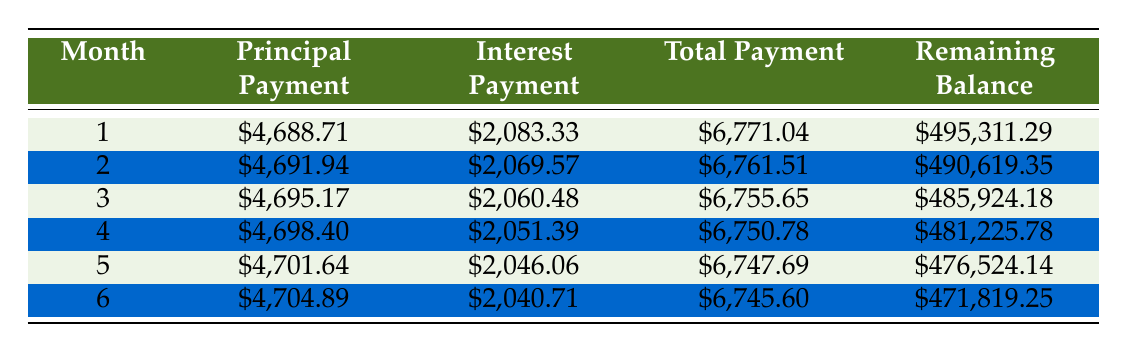What is the principal payment in the first month? The table shows the principal payment for month 1 as $4,688.71. Thus, the answer can be directly retrieved from the first row under the Principal Payment column.
Answer: 4,688.71 What is the total payment for month 3? The table indicates that the total payment for month 3 is $6,755.65. This value can be found in the row corresponding to month 3 in the Total Payment column.
Answer: 6,755.65 Is the interest payment for month 2 greater than that for month 1? The interest payment for month 2 is $2,069.57 and for month 1, it is $2,083.33. Since $2,069.57 is less than $2,083.33, the answer is no.
Answer: No What is the total of the principal payments for the first six months? To find the total of the principal payments, add the amounts from the principal payment column for the first six months: $4,688.71 + $4,691.94 + $4,695.17 + $4,698.40 + $4,701.64 + $4,704.89 = $28,480.75. This gives the total amount of principal paid over these six months.
Answer: 28,480.75 What month has the highest interest payment? Reviewing the interest payments for each month, the highest payment occurs in month 1 at $2,083.33. This can be concluded by comparing the interest payment values across all rows.
Answer: Month 1 What is the remaining balance after the 6th month? The remaining balance after the 6th month can be found in the table in the row corresponding to month 6. It shows $471,819.25, which is the remaining loan amount after six payments.
Answer: 471,819.25 If you sum up the total payments for the first three months, what is the total? To find the total payments for the first three months, sum the total payments for each month: $6,771.04 (month 1) + $6,761.51 (month 2) + $6,755.65 (month 3) = $20,288.20. Thus, this provides the total outflow associated with these payments.
Answer: 20,288.20 Is the expected monthly revenue greater than the total payments in the first month? The expected monthly revenue is $6,000, and the total payment for month 1 is $6,771.04. Since $6,000 is less than $6,771.04, the answer is no.
Answer: No How much has been paid off in principal after the first three months? To determine how much has been paid off in principal after three months, add the principal payments for month 1, month 2, and month 3: $4,688.71 + $4,691.94 + $4,695.17 = $14,075.82. This gives us the total amount of the loan that has been repaid due to principal payments over these months.
Answer: 14,075.82 